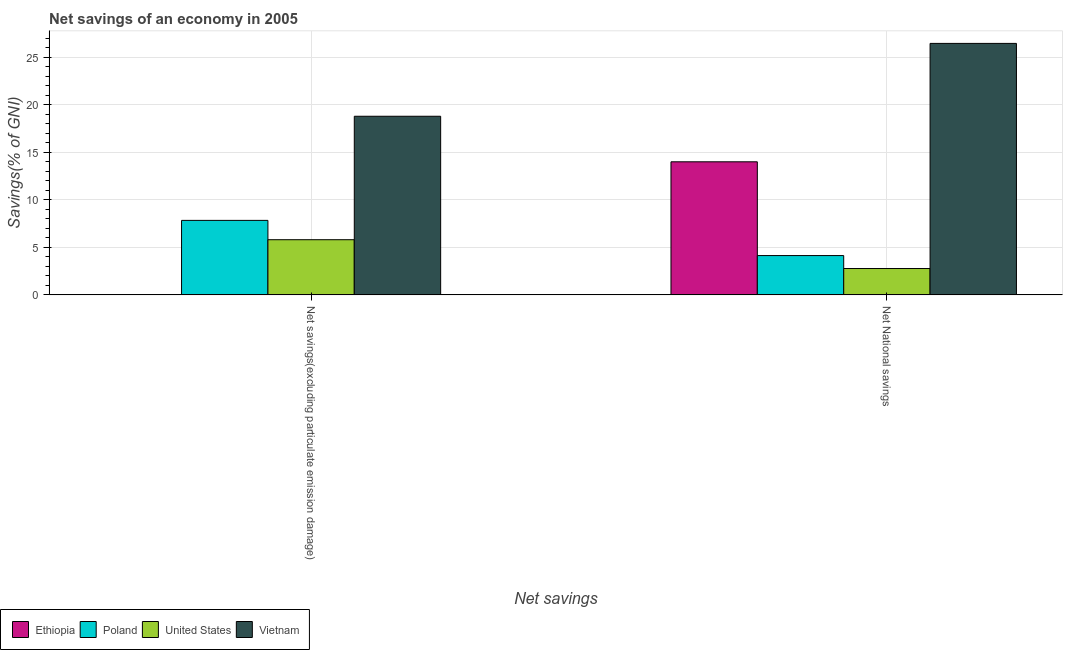How many different coloured bars are there?
Your answer should be very brief. 4. How many bars are there on the 2nd tick from the left?
Your answer should be very brief. 4. How many bars are there on the 1st tick from the right?
Ensure brevity in your answer.  4. What is the label of the 1st group of bars from the left?
Make the answer very short. Net savings(excluding particulate emission damage). What is the net savings(excluding particulate emission damage) in United States?
Provide a short and direct response. 5.81. Across all countries, what is the maximum net national savings?
Make the answer very short. 26.46. Across all countries, what is the minimum net national savings?
Give a very brief answer. 2.77. In which country was the net savings(excluding particulate emission damage) maximum?
Your answer should be very brief. Vietnam. What is the total net national savings in the graph?
Your answer should be compact. 47.38. What is the difference between the net savings(excluding particulate emission damage) in United States and that in Poland?
Ensure brevity in your answer.  -2.03. What is the difference between the net savings(excluding particulate emission damage) in Poland and the net national savings in Ethiopia?
Provide a succinct answer. -6.16. What is the average net savings(excluding particulate emission damage) per country?
Provide a succinct answer. 8.11. What is the difference between the net national savings and net savings(excluding particulate emission damage) in Poland?
Offer a very short reply. -3.7. What is the ratio of the net savings(excluding particulate emission damage) in Poland to that in Vietnam?
Ensure brevity in your answer.  0.42. Is the net national savings in Ethiopia less than that in Vietnam?
Make the answer very short. Yes. In how many countries, is the net savings(excluding particulate emission damage) greater than the average net savings(excluding particulate emission damage) taken over all countries?
Provide a succinct answer. 1. How many bars are there?
Ensure brevity in your answer.  7. Where does the legend appear in the graph?
Make the answer very short. Bottom left. What is the title of the graph?
Provide a succinct answer. Net savings of an economy in 2005. What is the label or title of the X-axis?
Provide a succinct answer. Net savings. What is the label or title of the Y-axis?
Provide a succinct answer. Savings(% of GNI). What is the Savings(% of GNI) of Ethiopia in Net savings(excluding particulate emission damage)?
Give a very brief answer. 0. What is the Savings(% of GNI) of Poland in Net savings(excluding particulate emission damage)?
Your answer should be compact. 7.84. What is the Savings(% of GNI) of United States in Net savings(excluding particulate emission damage)?
Keep it short and to the point. 5.81. What is the Savings(% of GNI) in Vietnam in Net savings(excluding particulate emission damage)?
Make the answer very short. 18.8. What is the Savings(% of GNI) in Ethiopia in Net National savings?
Your answer should be very brief. 14.01. What is the Savings(% of GNI) of Poland in Net National savings?
Offer a very short reply. 4.14. What is the Savings(% of GNI) in United States in Net National savings?
Your answer should be very brief. 2.77. What is the Savings(% of GNI) of Vietnam in Net National savings?
Make the answer very short. 26.46. Across all Net savings, what is the maximum Savings(% of GNI) in Ethiopia?
Your response must be concise. 14.01. Across all Net savings, what is the maximum Savings(% of GNI) in Poland?
Provide a short and direct response. 7.84. Across all Net savings, what is the maximum Savings(% of GNI) in United States?
Provide a succinct answer. 5.81. Across all Net savings, what is the maximum Savings(% of GNI) in Vietnam?
Offer a very short reply. 26.46. Across all Net savings, what is the minimum Savings(% of GNI) of Ethiopia?
Provide a short and direct response. 0. Across all Net savings, what is the minimum Savings(% of GNI) in Poland?
Offer a terse response. 4.14. Across all Net savings, what is the minimum Savings(% of GNI) of United States?
Your response must be concise. 2.77. Across all Net savings, what is the minimum Savings(% of GNI) in Vietnam?
Provide a succinct answer. 18.8. What is the total Savings(% of GNI) in Ethiopia in the graph?
Make the answer very short. 14.01. What is the total Savings(% of GNI) in Poland in the graph?
Offer a very short reply. 11.98. What is the total Savings(% of GNI) of United States in the graph?
Give a very brief answer. 8.58. What is the total Savings(% of GNI) of Vietnam in the graph?
Provide a short and direct response. 45.26. What is the difference between the Savings(% of GNI) of Poland in Net savings(excluding particulate emission damage) and that in Net National savings?
Offer a very short reply. 3.7. What is the difference between the Savings(% of GNI) in United States in Net savings(excluding particulate emission damage) and that in Net National savings?
Provide a short and direct response. 3.03. What is the difference between the Savings(% of GNI) in Vietnam in Net savings(excluding particulate emission damage) and that in Net National savings?
Your response must be concise. -7.67. What is the difference between the Savings(% of GNI) of Poland in Net savings(excluding particulate emission damage) and the Savings(% of GNI) of United States in Net National savings?
Provide a short and direct response. 5.07. What is the difference between the Savings(% of GNI) of Poland in Net savings(excluding particulate emission damage) and the Savings(% of GNI) of Vietnam in Net National savings?
Your answer should be very brief. -18.62. What is the difference between the Savings(% of GNI) of United States in Net savings(excluding particulate emission damage) and the Savings(% of GNI) of Vietnam in Net National savings?
Your response must be concise. -20.66. What is the average Savings(% of GNI) of Ethiopia per Net savings?
Your answer should be very brief. 7. What is the average Savings(% of GNI) of Poland per Net savings?
Your answer should be very brief. 5.99. What is the average Savings(% of GNI) in United States per Net savings?
Your answer should be compact. 4.29. What is the average Savings(% of GNI) of Vietnam per Net savings?
Give a very brief answer. 22.63. What is the difference between the Savings(% of GNI) of Poland and Savings(% of GNI) of United States in Net savings(excluding particulate emission damage)?
Give a very brief answer. 2.03. What is the difference between the Savings(% of GNI) in Poland and Savings(% of GNI) in Vietnam in Net savings(excluding particulate emission damage)?
Provide a succinct answer. -10.96. What is the difference between the Savings(% of GNI) of United States and Savings(% of GNI) of Vietnam in Net savings(excluding particulate emission damage)?
Your answer should be compact. -12.99. What is the difference between the Savings(% of GNI) in Ethiopia and Savings(% of GNI) in Poland in Net National savings?
Keep it short and to the point. 9.87. What is the difference between the Savings(% of GNI) of Ethiopia and Savings(% of GNI) of United States in Net National savings?
Provide a succinct answer. 11.23. What is the difference between the Savings(% of GNI) of Ethiopia and Savings(% of GNI) of Vietnam in Net National savings?
Make the answer very short. -12.46. What is the difference between the Savings(% of GNI) in Poland and Savings(% of GNI) in United States in Net National savings?
Ensure brevity in your answer.  1.36. What is the difference between the Savings(% of GNI) of Poland and Savings(% of GNI) of Vietnam in Net National savings?
Ensure brevity in your answer.  -22.33. What is the difference between the Savings(% of GNI) of United States and Savings(% of GNI) of Vietnam in Net National savings?
Your answer should be compact. -23.69. What is the ratio of the Savings(% of GNI) in Poland in Net savings(excluding particulate emission damage) to that in Net National savings?
Your answer should be very brief. 1.89. What is the ratio of the Savings(% of GNI) of United States in Net savings(excluding particulate emission damage) to that in Net National savings?
Offer a very short reply. 2.09. What is the ratio of the Savings(% of GNI) in Vietnam in Net savings(excluding particulate emission damage) to that in Net National savings?
Give a very brief answer. 0.71. What is the difference between the highest and the second highest Savings(% of GNI) in Poland?
Your answer should be compact. 3.7. What is the difference between the highest and the second highest Savings(% of GNI) of United States?
Ensure brevity in your answer.  3.03. What is the difference between the highest and the second highest Savings(% of GNI) in Vietnam?
Make the answer very short. 7.67. What is the difference between the highest and the lowest Savings(% of GNI) of Ethiopia?
Your answer should be very brief. 14.01. What is the difference between the highest and the lowest Savings(% of GNI) in Poland?
Give a very brief answer. 3.7. What is the difference between the highest and the lowest Savings(% of GNI) of United States?
Give a very brief answer. 3.03. What is the difference between the highest and the lowest Savings(% of GNI) in Vietnam?
Offer a very short reply. 7.67. 